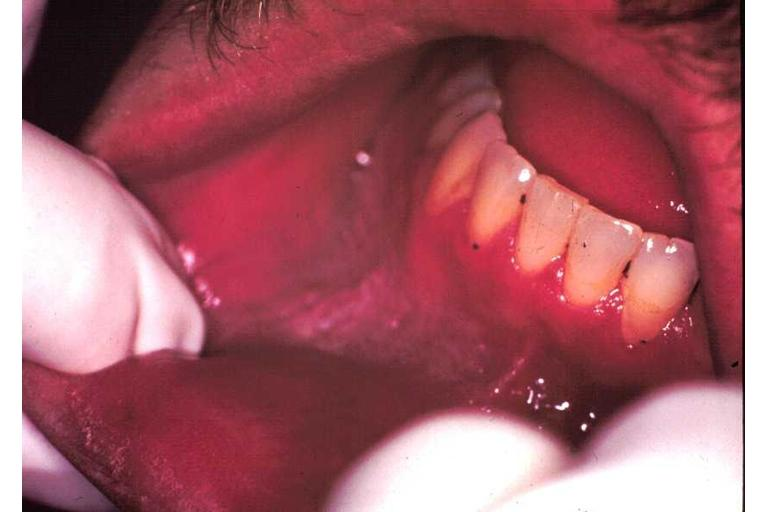s oral present?
Answer the question using a single word or phrase. Yes 